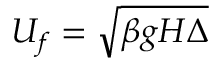Convert formula to latex. <formula><loc_0><loc_0><loc_500><loc_500>U _ { f } = \sqrt { \beta g H \Delta }</formula> 